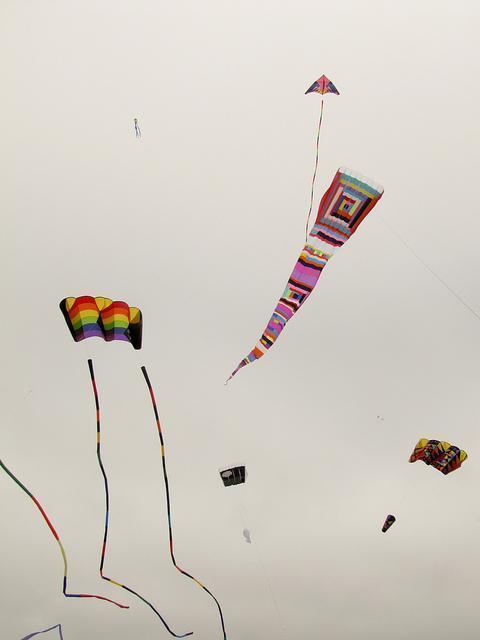What is rising in the air?
Make your selection from the four choices given to correctly answer the question.
Options: Airplane, balloon, kite, butterfly. Kite. 